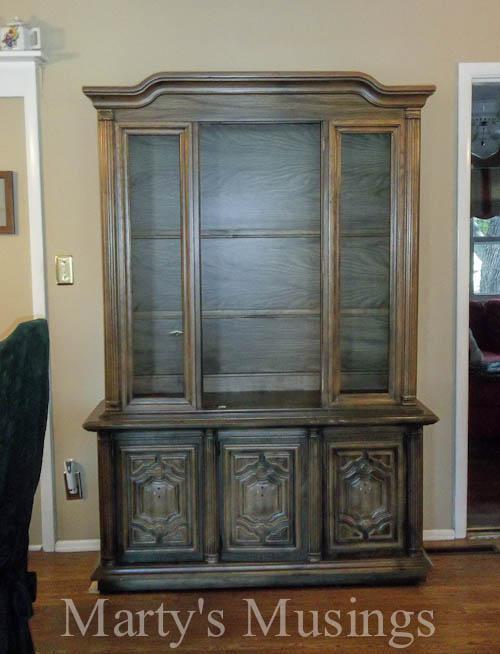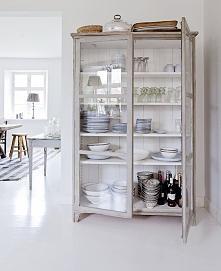The first image is the image on the left, the second image is the image on the right. Assess this claim about the two images: "A wooden hutch with three rows of dishes in its upper section has at least two drawers with pulls between doors in the bottom section.". Correct or not? Answer yes or no. No. The first image is the image on the left, the second image is the image on the right. Considering the images on both sides, is "At least one of the cabinets has an arched top as well as some type of legs." valid? Answer yes or no. No. 